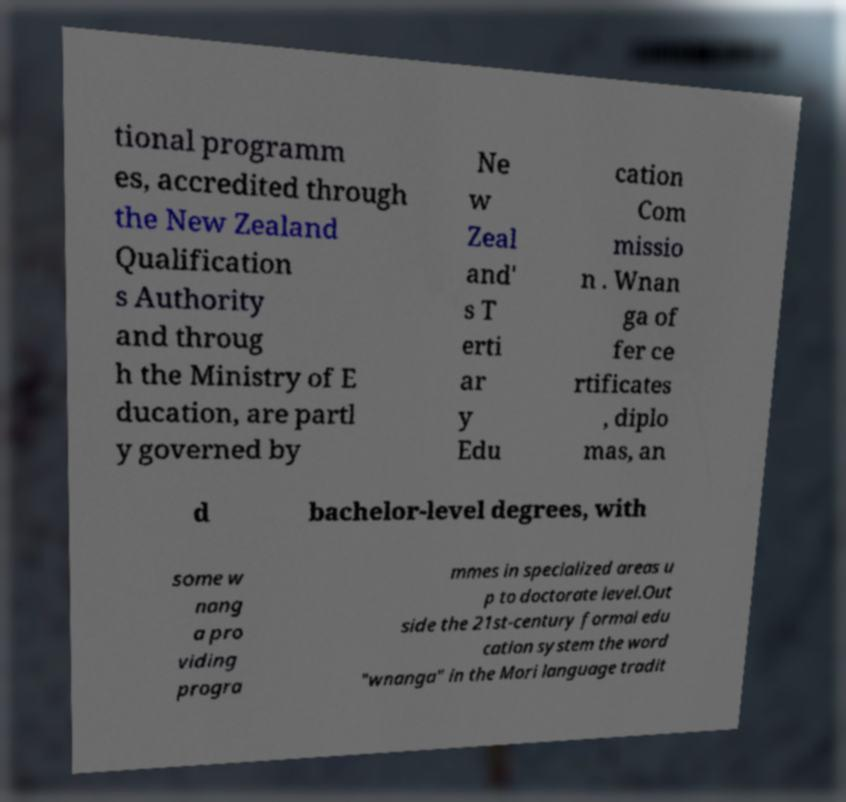Please read and relay the text visible in this image. What does it say? tional programm es, accredited through the New Zealand Qualification s Authority and throug h the Ministry of E ducation, are partl y governed by Ne w Zeal and' s T erti ar y Edu cation Com missio n . Wnan ga of fer ce rtificates , diplo mas, an d bachelor-level degrees, with some w nang a pro viding progra mmes in specialized areas u p to doctorate level.Out side the 21st-century formal edu cation system the word "wnanga" in the Mori language tradit 